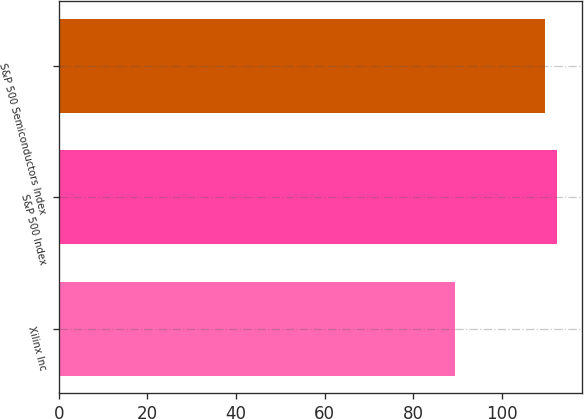Convert chart to OTSL. <chart><loc_0><loc_0><loc_500><loc_500><bar_chart><fcel>Xilinx Inc<fcel>S&P 500 Index<fcel>S&P 500 Semiconductors Index<nl><fcel>89.4<fcel>112.46<fcel>109.7<nl></chart> 